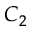Convert formula to latex. <formula><loc_0><loc_0><loc_500><loc_500>C _ { 2 }</formula> 